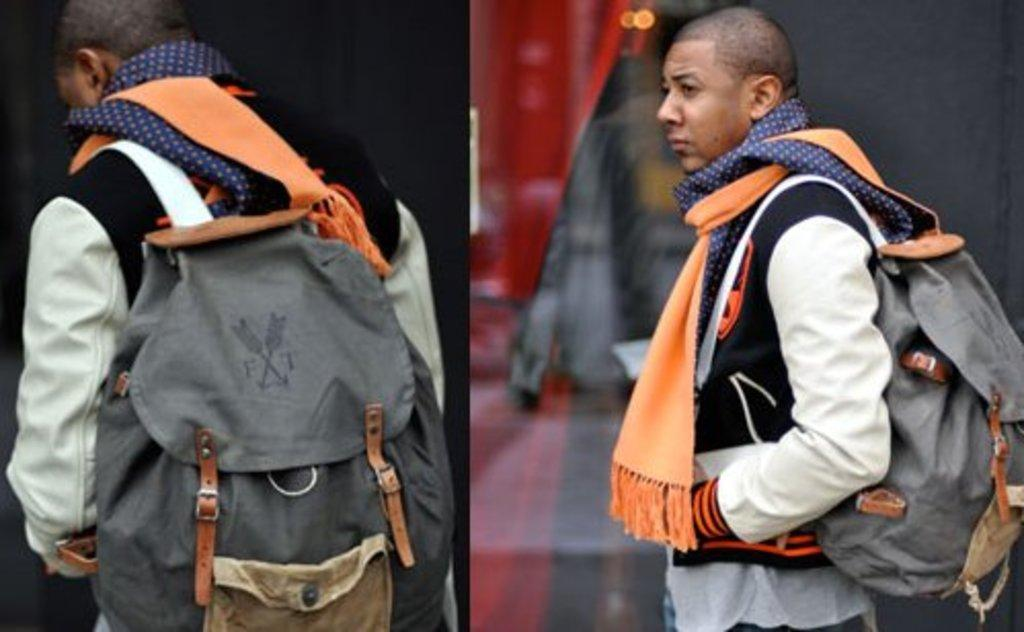<image>
Create a compact narrative representing the image presented. A posh fellow with many scarves carrying an FT backpack. 